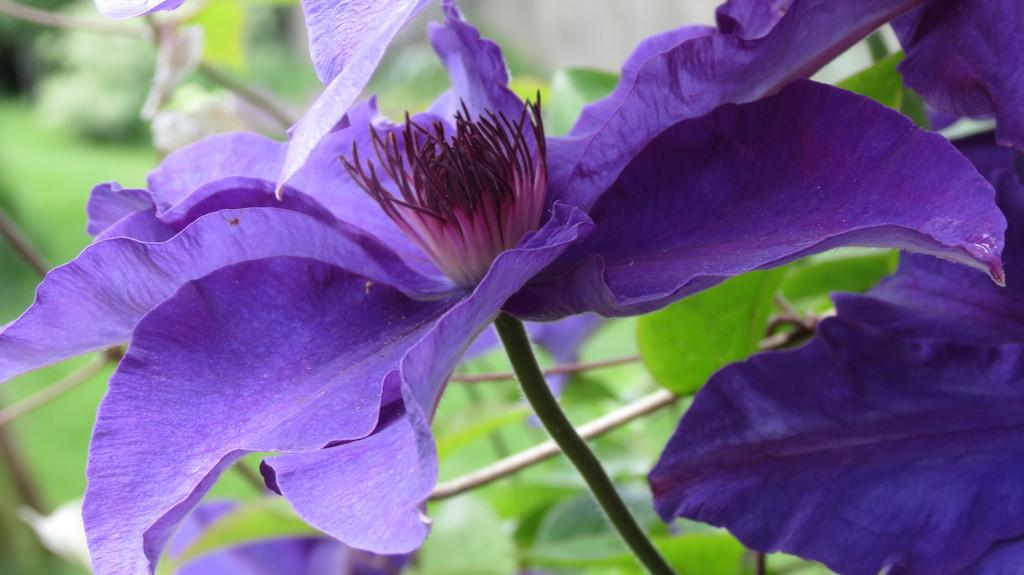What type of plant life is present in the image? There are flowers in the image. What color are the flowers? The flowers are violet in color. What are the main features of the flowers? The flowers have petals and a stem. Are there any additional parts of the flowers visible in the image? Yes, there are leaves on the flowers. How would you describe the background of the image? The background of the image appears blurry. How does the pollution affect the flowers in the image? There is no indication of pollution in the image, so it cannot be determined how it might affect the flowers. 